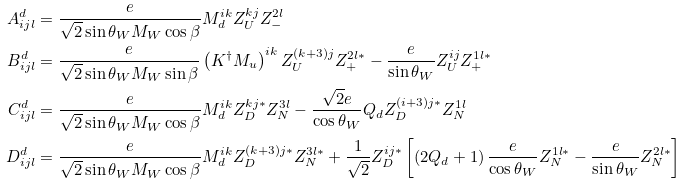<formula> <loc_0><loc_0><loc_500><loc_500>A ^ { d } _ { i j l } & = \frac { e } { \sqrt { 2 } \sin \theta _ { W } M _ { W } \cos \beta } M _ { d } ^ { i k } Z _ { U } ^ { k j } Z _ { - } ^ { 2 l } \\ B ^ { d } _ { i j l } & = \frac { e } { \sqrt { 2 } \sin \theta _ { W } M _ { W } \sin \beta } \left ( K ^ { \dagger } M _ { u } \right ) ^ { i k } Z _ { U } ^ { ( k + 3 ) j } Z _ { + } ^ { 2 l * } - \frac { e } { \sin \theta _ { W } } Z _ { U } ^ { i j } Z _ { + } ^ { 1 l * } \\ C ^ { d } _ { i j l } & = \frac { e } { \sqrt { 2 } \sin \theta _ { W } M _ { W } \cos \beta } M _ { d } ^ { i k } Z _ { D } ^ { k j * } Z _ { N } ^ { 3 l } - \frac { \sqrt { 2 } e } { \cos \theta _ { W } } Q _ { d } Z _ { D } ^ { ( i + 3 ) j * } Z _ { N } ^ { 1 l } \\ D ^ { d } _ { i j l } & = \frac { e } { \sqrt { 2 } \sin \theta _ { W } M _ { W } \cos \beta } M _ { d } ^ { i k } Z _ { D } ^ { ( k + 3 ) j * } Z _ { N } ^ { 3 l * } + \frac { 1 } { \sqrt { 2 } } Z _ { D } ^ { i j * } \left [ \left ( 2 Q _ { d } + 1 \right ) \frac { e } { \cos \theta _ { W } } Z _ { N } ^ { 1 l * } - \frac { e } { \sin \theta _ { W } } Z _ { N } ^ { 2 l * } \right ]</formula> 